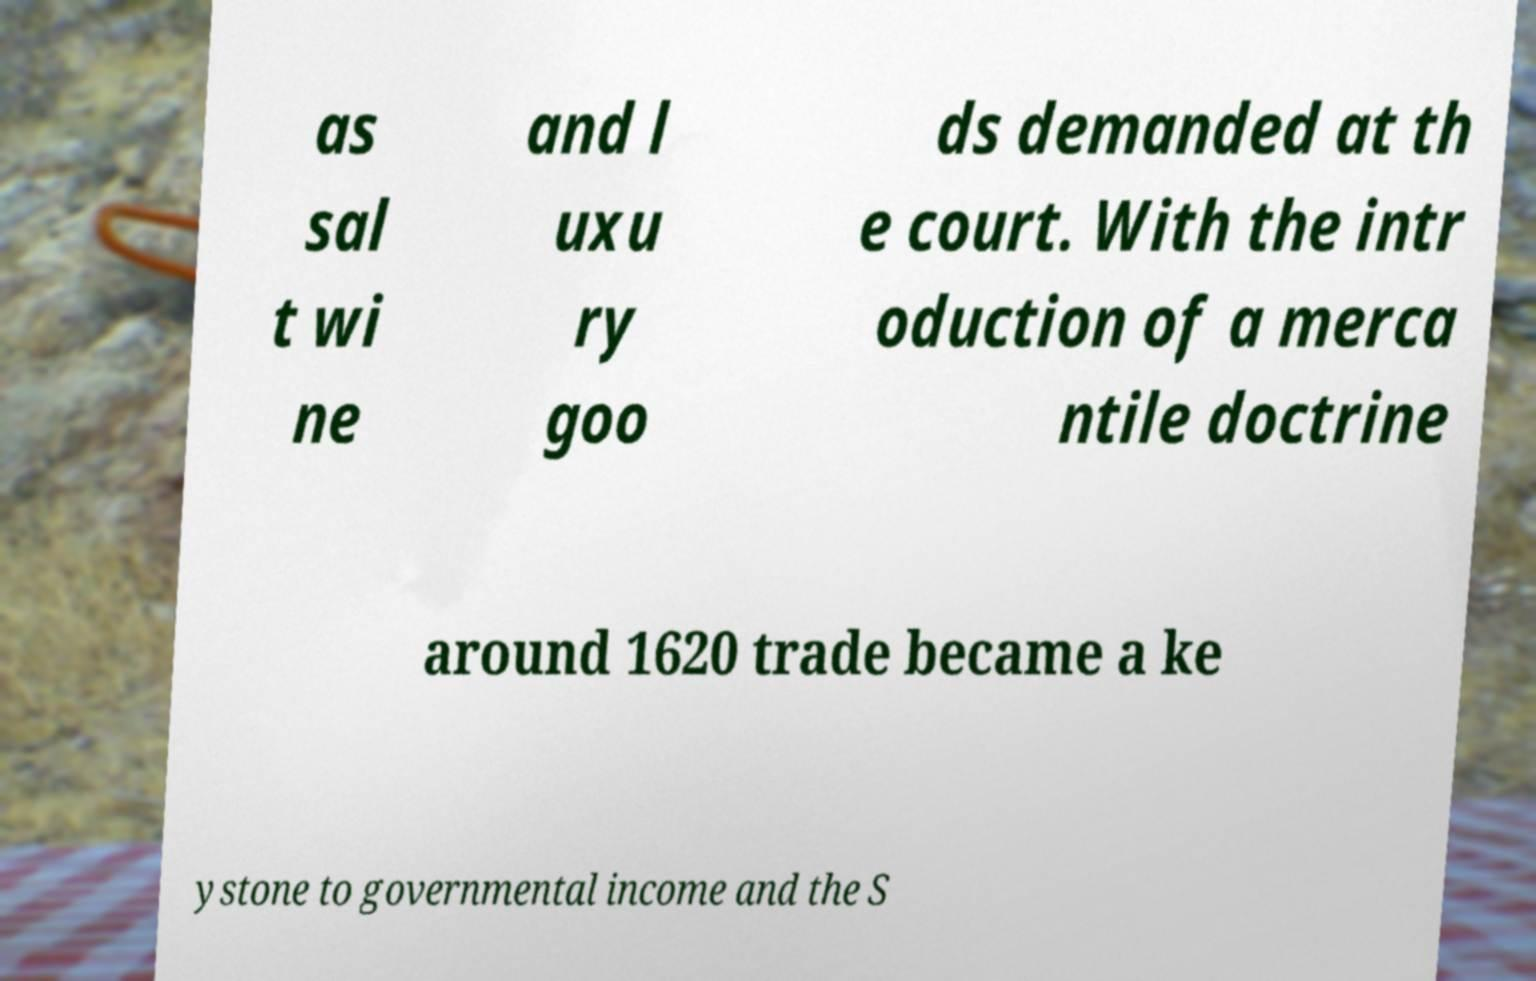What messages or text are displayed in this image? I need them in a readable, typed format. as sal t wi ne and l uxu ry goo ds demanded at th e court. With the intr oduction of a merca ntile doctrine around 1620 trade became a ke ystone to governmental income and the S 